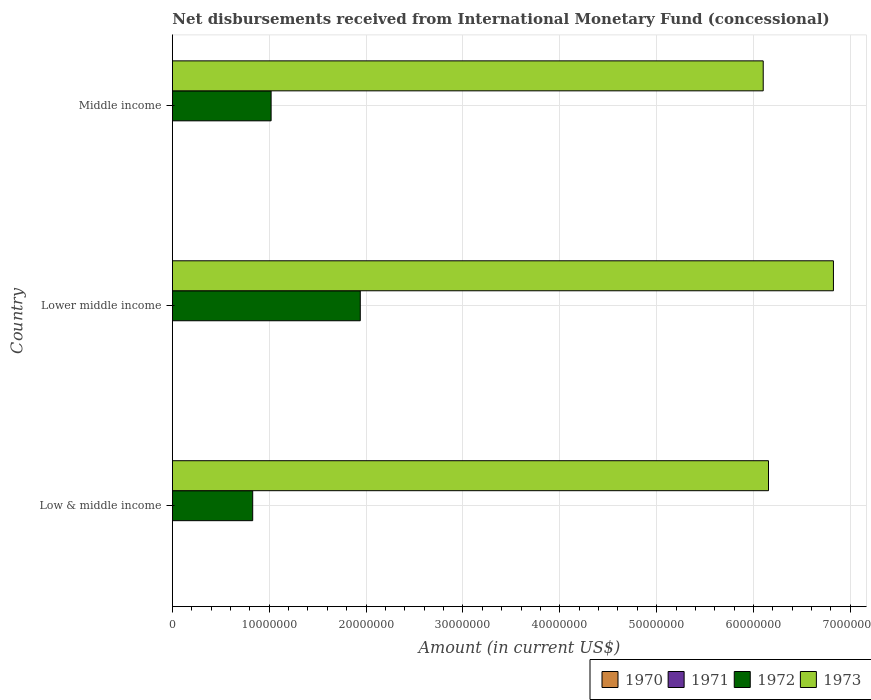How many different coloured bars are there?
Ensure brevity in your answer.  2. How many groups of bars are there?
Offer a terse response. 3. Are the number of bars per tick equal to the number of legend labels?
Keep it short and to the point. No. What is the label of the 3rd group of bars from the top?
Your answer should be very brief. Low & middle income. What is the amount of disbursements received from International Monetary Fund in 1972 in Lower middle income?
Your answer should be very brief. 1.94e+07. Across all countries, what is the maximum amount of disbursements received from International Monetary Fund in 1973?
Your answer should be compact. 6.83e+07. In which country was the amount of disbursements received from International Monetary Fund in 1973 maximum?
Make the answer very short. Lower middle income. What is the total amount of disbursements received from International Monetary Fund in 1972 in the graph?
Keep it short and to the point. 3.79e+07. What is the difference between the amount of disbursements received from International Monetary Fund in 1972 in Low & middle income and that in Lower middle income?
Offer a very short reply. -1.11e+07. What is the difference between the amount of disbursements received from International Monetary Fund in 1972 in Lower middle income and the amount of disbursements received from International Monetary Fund in 1971 in Low & middle income?
Offer a very short reply. 1.94e+07. What is the average amount of disbursements received from International Monetary Fund in 1973 per country?
Keep it short and to the point. 6.36e+07. What is the difference between the amount of disbursements received from International Monetary Fund in 1972 and amount of disbursements received from International Monetary Fund in 1973 in Low & middle income?
Your answer should be very brief. -5.33e+07. In how many countries, is the amount of disbursements received from International Monetary Fund in 1972 greater than 68000000 US$?
Keep it short and to the point. 0. What is the ratio of the amount of disbursements received from International Monetary Fund in 1972 in Low & middle income to that in Lower middle income?
Keep it short and to the point. 0.43. Is the difference between the amount of disbursements received from International Monetary Fund in 1972 in Lower middle income and Middle income greater than the difference between the amount of disbursements received from International Monetary Fund in 1973 in Lower middle income and Middle income?
Provide a succinct answer. Yes. What is the difference between the highest and the second highest amount of disbursements received from International Monetary Fund in 1972?
Offer a very short reply. 9.21e+06. What is the difference between the highest and the lowest amount of disbursements received from International Monetary Fund in 1972?
Your answer should be compact. 1.11e+07. Is the sum of the amount of disbursements received from International Monetary Fund in 1972 in Low & middle income and Lower middle income greater than the maximum amount of disbursements received from International Monetary Fund in 1970 across all countries?
Your answer should be very brief. Yes. How many bars are there?
Provide a succinct answer. 6. Are all the bars in the graph horizontal?
Provide a succinct answer. Yes. How many countries are there in the graph?
Your answer should be compact. 3. Are the values on the major ticks of X-axis written in scientific E-notation?
Offer a very short reply. No. Does the graph contain grids?
Your response must be concise. Yes. Where does the legend appear in the graph?
Offer a very short reply. Bottom right. How are the legend labels stacked?
Offer a terse response. Horizontal. What is the title of the graph?
Your answer should be compact. Net disbursements received from International Monetary Fund (concessional). What is the Amount (in current US$) of 1971 in Low & middle income?
Ensure brevity in your answer.  0. What is the Amount (in current US$) of 1972 in Low & middle income?
Offer a very short reply. 8.30e+06. What is the Amount (in current US$) of 1973 in Low & middle income?
Your answer should be very brief. 6.16e+07. What is the Amount (in current US$) in 1970 in Lower middle income?
Your answer should be very brief. 0. What is the Amount (in current US$) of 1972 in Lower middle income?
Provide a succinct answer. 1.94e+07. What is the Amount (in current US$) of 1973 in Lower middle income?
Offer a very short reply. 6.83e+07. What is the Amount (in current US$) in 1971 in Middle income?
Give a very brief answer. 0. What is the Amount (in current US$) of 1972 in Middle income?
Ensure brevity in your answer.  1.02e+07. What is the Amount (in current US$) of 1973 in Middle income?
Keep it short and to the point. 6.10e+07. Across all countries, what is the maximum Amount (in current US$) in 1972?
Offer a very short reply. 1.94e+07. Across all countries, what is the maximum Amount (in current US$) in 1973?
Provide a succinct answer. 6.83e+07. Across all countries, what is the minimum Amount (in current US$) in 1972?
Your response must be concise. 8.30e+06. Across all countries, what is the minimum Amount (in current US$) in 1973?
Give a very brief answer. 6.10e+07. What is the total Amount (in current US$) of 1970 in the graph?
Your response must be concise. 0. What is the total Amount (in current US$) in 1972 in the graph?
Give a very brief answer. 3.79e+07. What is the total Amount (in current US$) in 1973 in the graph?
Provide a short and direct response. 1.91e+08. What is the difference between the Amount (in current US$) in 1972 in Low & middle income and that in Lower middle income?
Give a very brief answer. -1.11e+07. What is the difference between the Amount (in current US$) of 1973 in Low & middle income and that in Lower middle income?
Ensure brevity in your answer.  -6.70e+06. What is the difference between the Amount (in current US$) in 1972 in Low & middle income and that in Middle income?
Provide a succinct answer. -1.90e+06. What is the difference between the Amount (in current US$) in 1973 in Low & middle income and that in Middle income?
Give a very brief answer. 5.46e+05. What is the difference between the Amount (in current US$) of 1972 in Lower middle income and that in Middle income?
Give a very brief answer. 9.21e+06. What is the difference between the Amount (in current US$) in 1973 in Lower middle income and that in Middle income?
Provide a succinct answer. 7.25e+06. What is the difference between the Amount (in current US$) of 1972 in Low & middle income and the Amount (in current US$) of 1973 in Lower middle income?
Your answer should be compact. -6.00e+07. What is the difference between the Amount (in current US$) in 1972 in Low & middle income and the Amount (in current US$) in 1973 in Middle income?
Your answer should be very brief. -5.27e+07. What is the difference between the Amount (in current US$) in 1972 in Lower middle income and the Amount (in current US$) in 1973 in Middle income?
Make the answer very short. -4.16e+07. What is the average Amount (in current US$) of 1972 per country?
Keep it short and to the point. 1.26e+07. What is the average Amount (in current US$) in 1973 per country?
Offer a very short reply. 6.36e+07. What is the difference between the Amount (in current US$) of 1972 and Amount (in current US$) of 1973 in Low & middle income?
Your answer should be compact. -5.33e+07. What is the difference between the Amount (in current US$) in 1972 and Amount (in current US$) in 1973 in Lower middle income?
Your response must be concise. -4.89e+07. What is the difference between the Amount (in current US$) of 1972 and Amount (in current US$) of 1973 in Middle income?
Your answer should be compact. -5.08e+07. What is the ratio of the Amount (in current US$) of 1972 in Low & middle income to that in Lower middle income?
Your answer should be very brief. 0.43. What is the ratio of the Amount (in current US$) in 1973 in Low & middle income to that in Lower middle income?
Offer a very short reply. 0.9. What is the ratio of the Amount (in current US$) in 1972 in Low & middle income to that in Middle income?
Provide a short and direct response. 0.81. What is the ratio of the Amount (in current US$) of 1972 in Lower middle income to that in Middle income?
Offer a very short reply. 1.9. What is the ratio of the Amount (in current US$) of 1973 in Lower middle income to that in Middle income?
Offer a terse response. 1.12. What is the difference between the highest and the second highest Amount (in current US$) in 1972?
Offer a terse response. 9.21e+06. What is the difference between the highest and the second highest Amount (in current US$) in 1973?
Make the answer very short. 6.70e+06. What is the difference between the highest and the lowest Amount (in current US$) in 1972?
Offer a terse response. 1.11e+07. What is the difference between the highest and the lowest Amount (in current US$) in 1973?
Keep it short and to the point. 7.25e+06. 